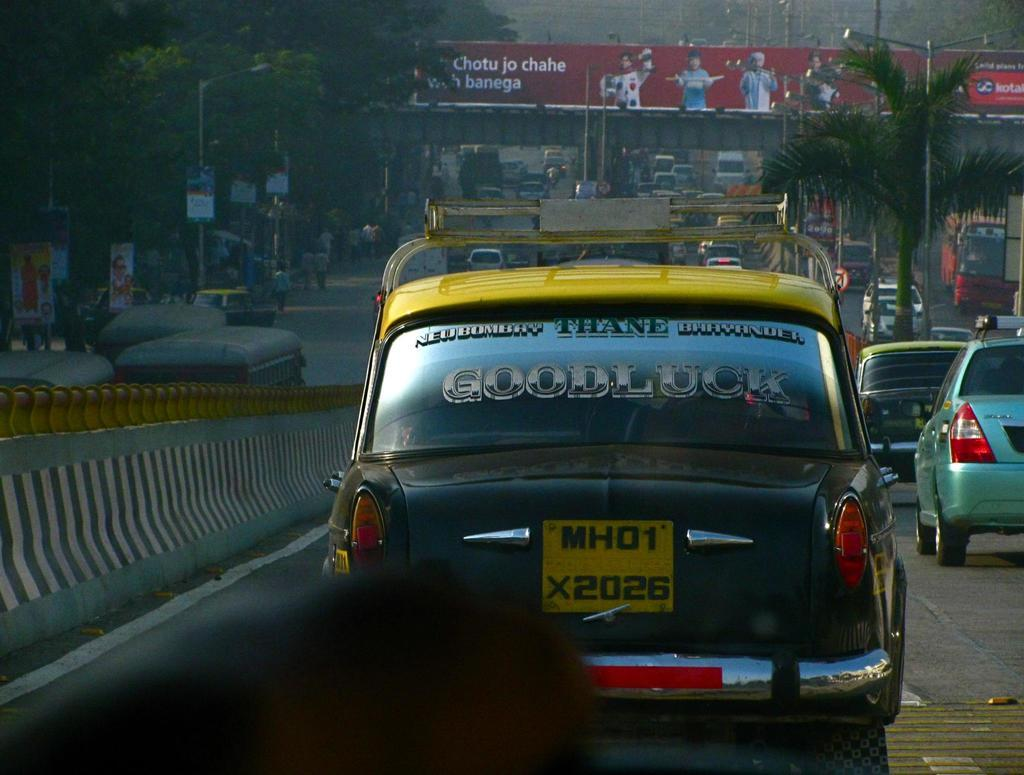<image>
Provide a brief description of the given image. A busy street has a car that says Good Luck on the back window. 